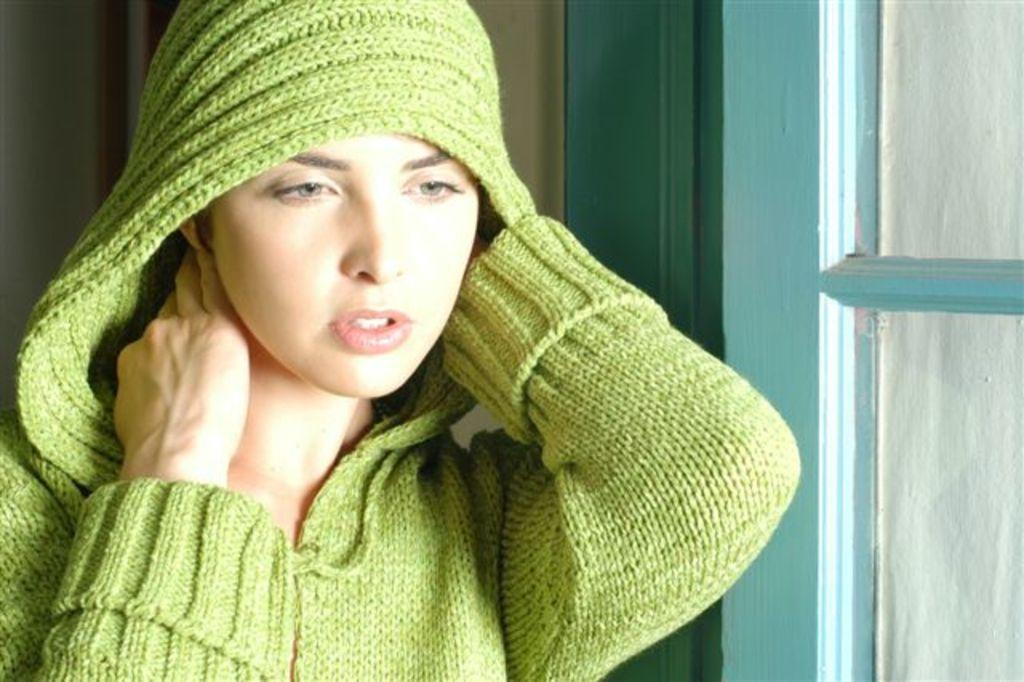Who or what is present in the image? There is a person in the image. What is the person wearing? The person is wearing a green dress. What can be seen in the background of the image? There is a window in the background of the image. What is the color of the window? The window is in blue color. What type of nerve can be seen in the image? There is no nerve present in the image; it features a person wearing a green dress with a window in the background. 